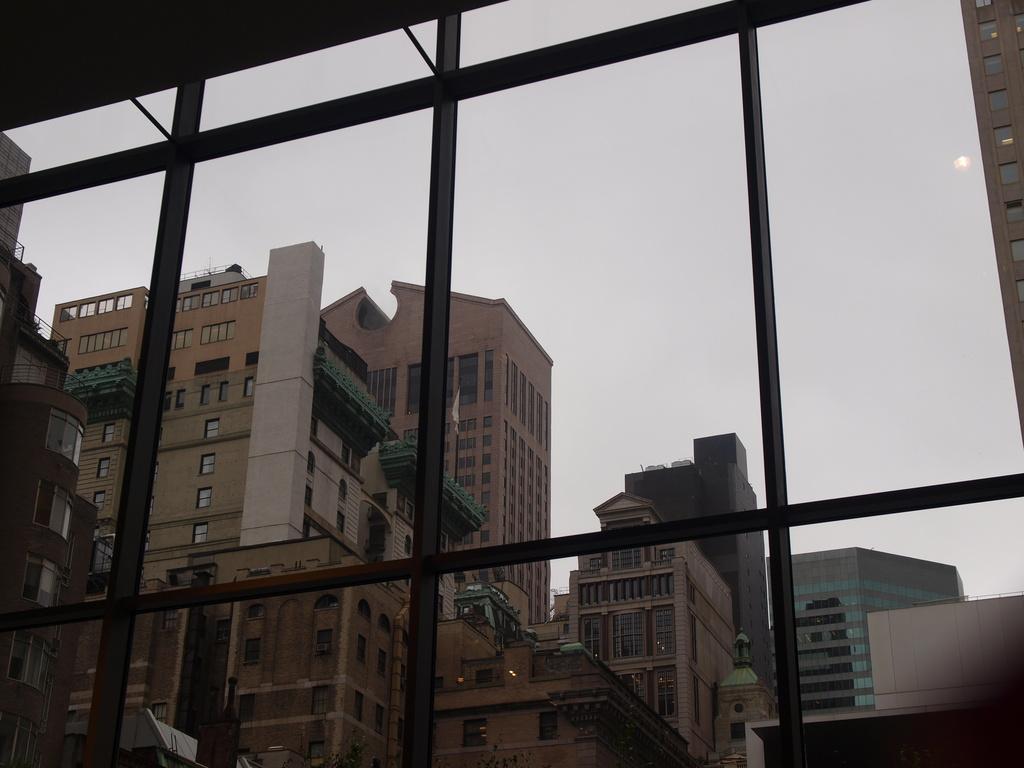How would you summarize this image in a sentence or two? In this image in the foreground there is a window and grills and through the window i can see some buildings and houses, at the top of the image there is sky. 